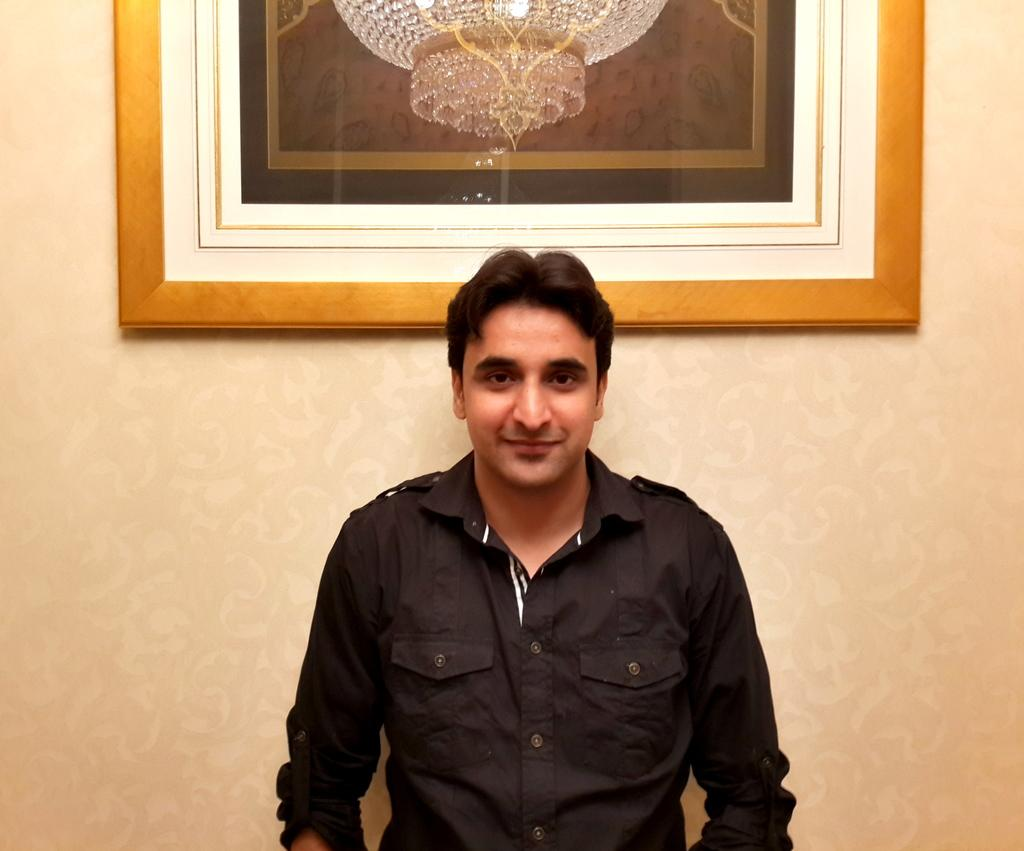What is present in the image? There is a man in the image. Can you describe anything on the wall in the background? There is a wall hanging attached to the wall in the background of the image. Did the earthquake cause the wall hanging to fall off the wall in the image? There is no indication of an earthquake or any damage to the wall hanging in the image. 